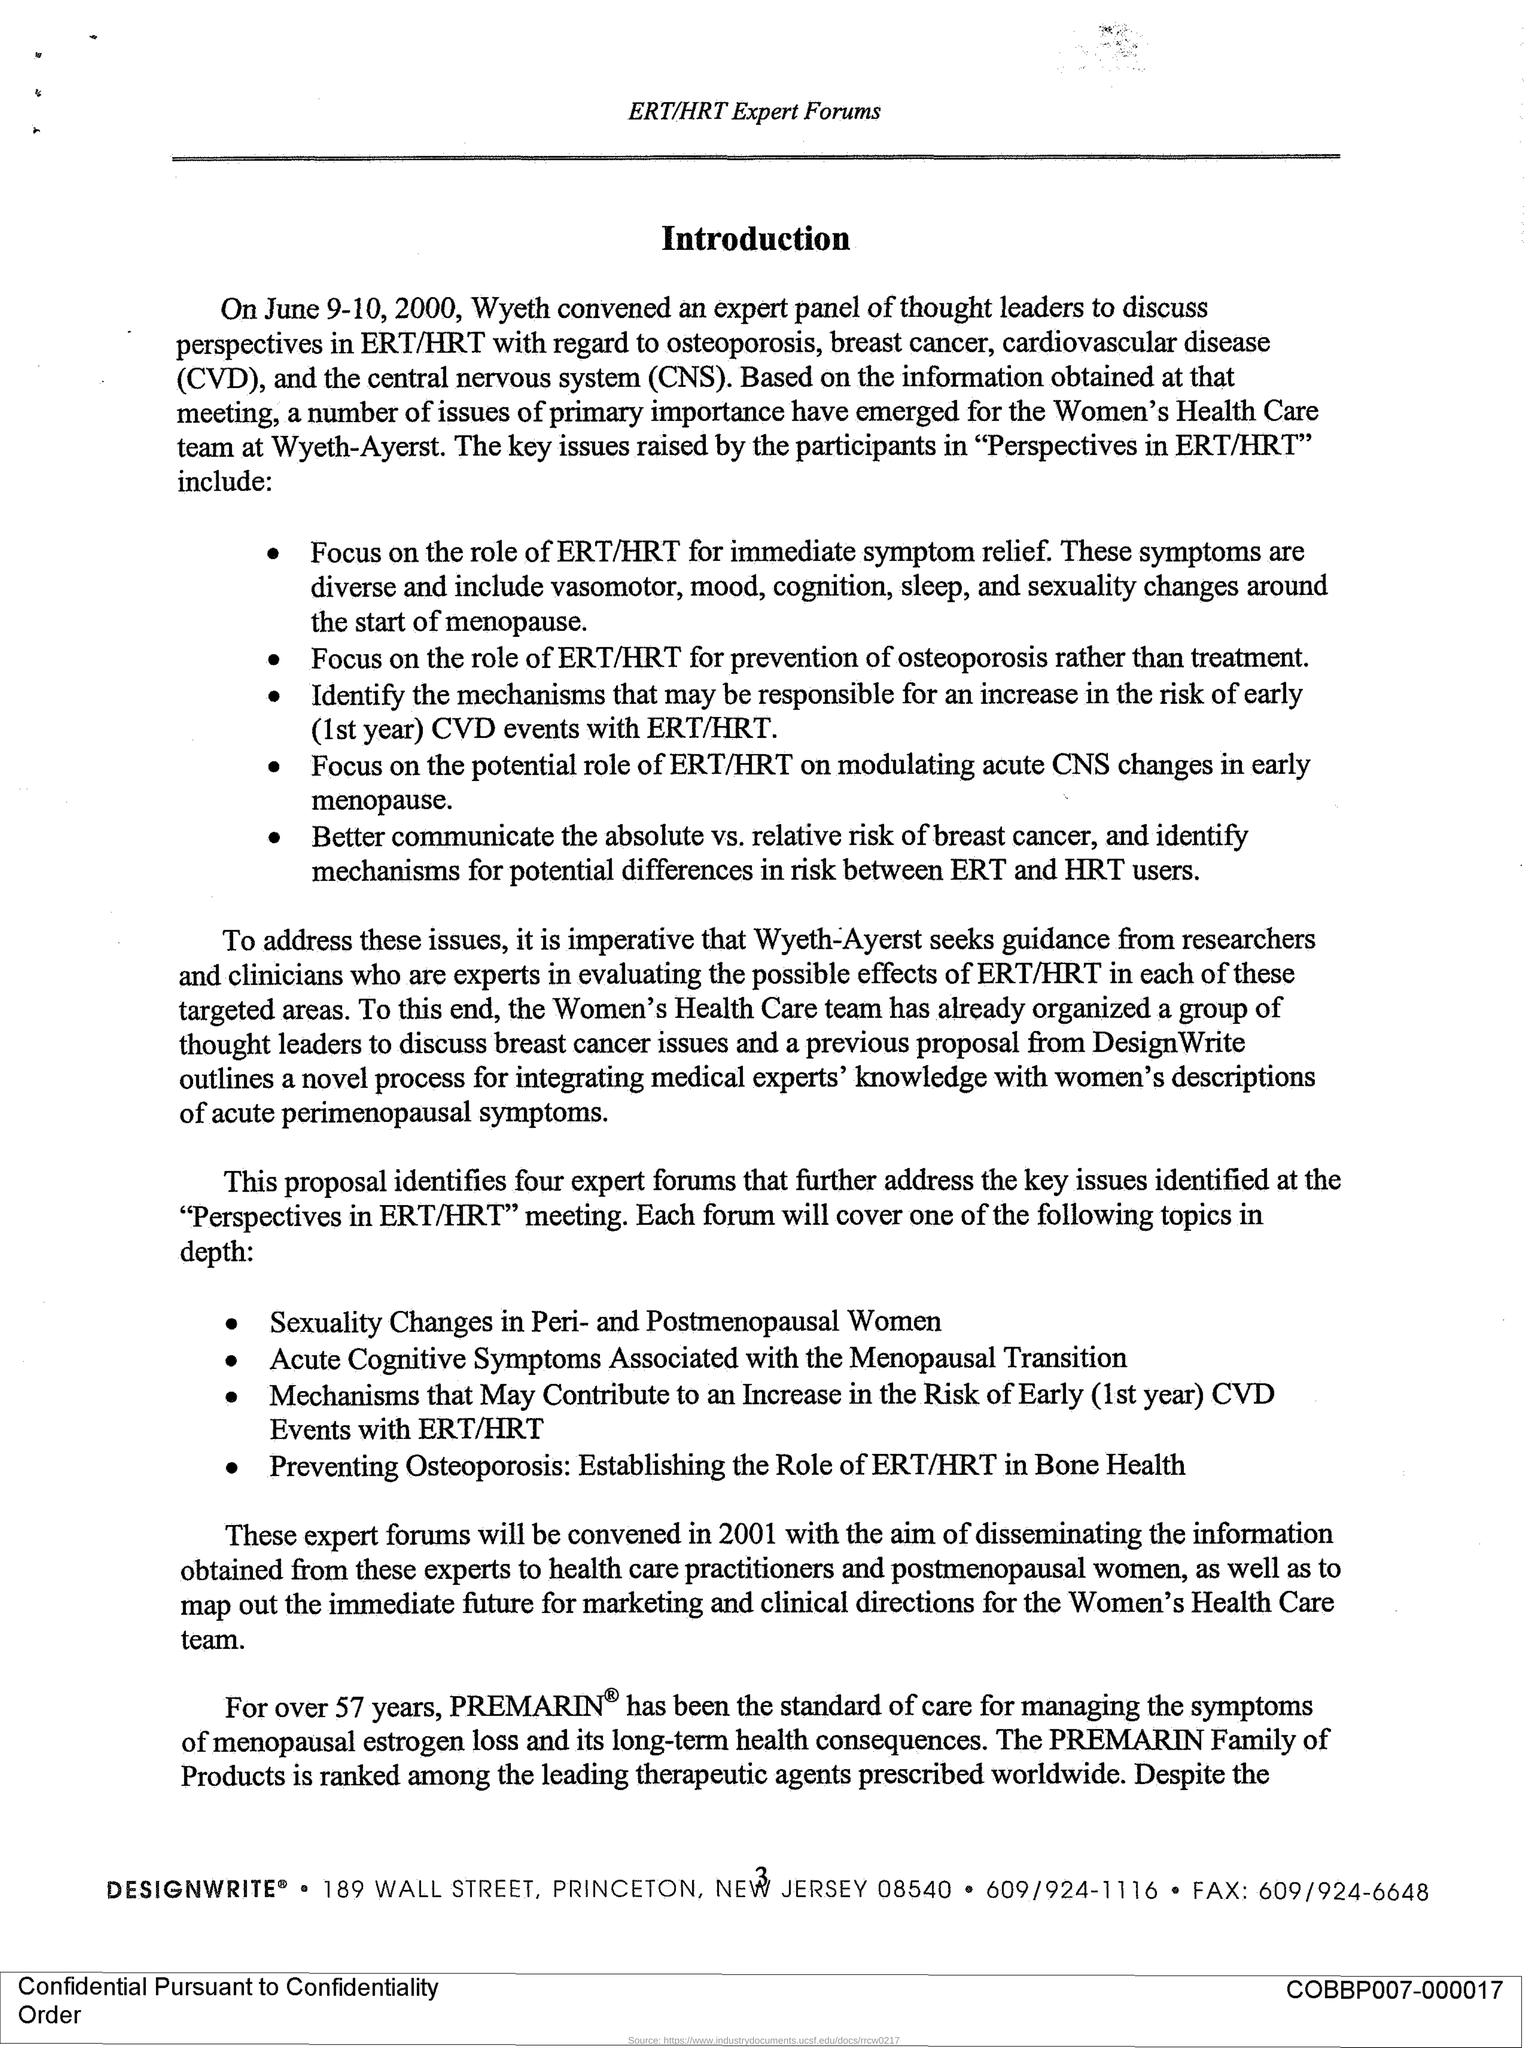When did Wyeth convene an expert panel of thought leaders?
Provide a succinct answer. June 9-10,2000. What does CVD stand for?
Your answer should be very brief. Cardiovascular disease. What does CNS stand for?
Your answer should be very brief. Central Nervous System. For how many years has PREMARIN been the standard pf care for managing symptoms of mepausal estrogen loss?
Give a very brief answer. 57 years. 